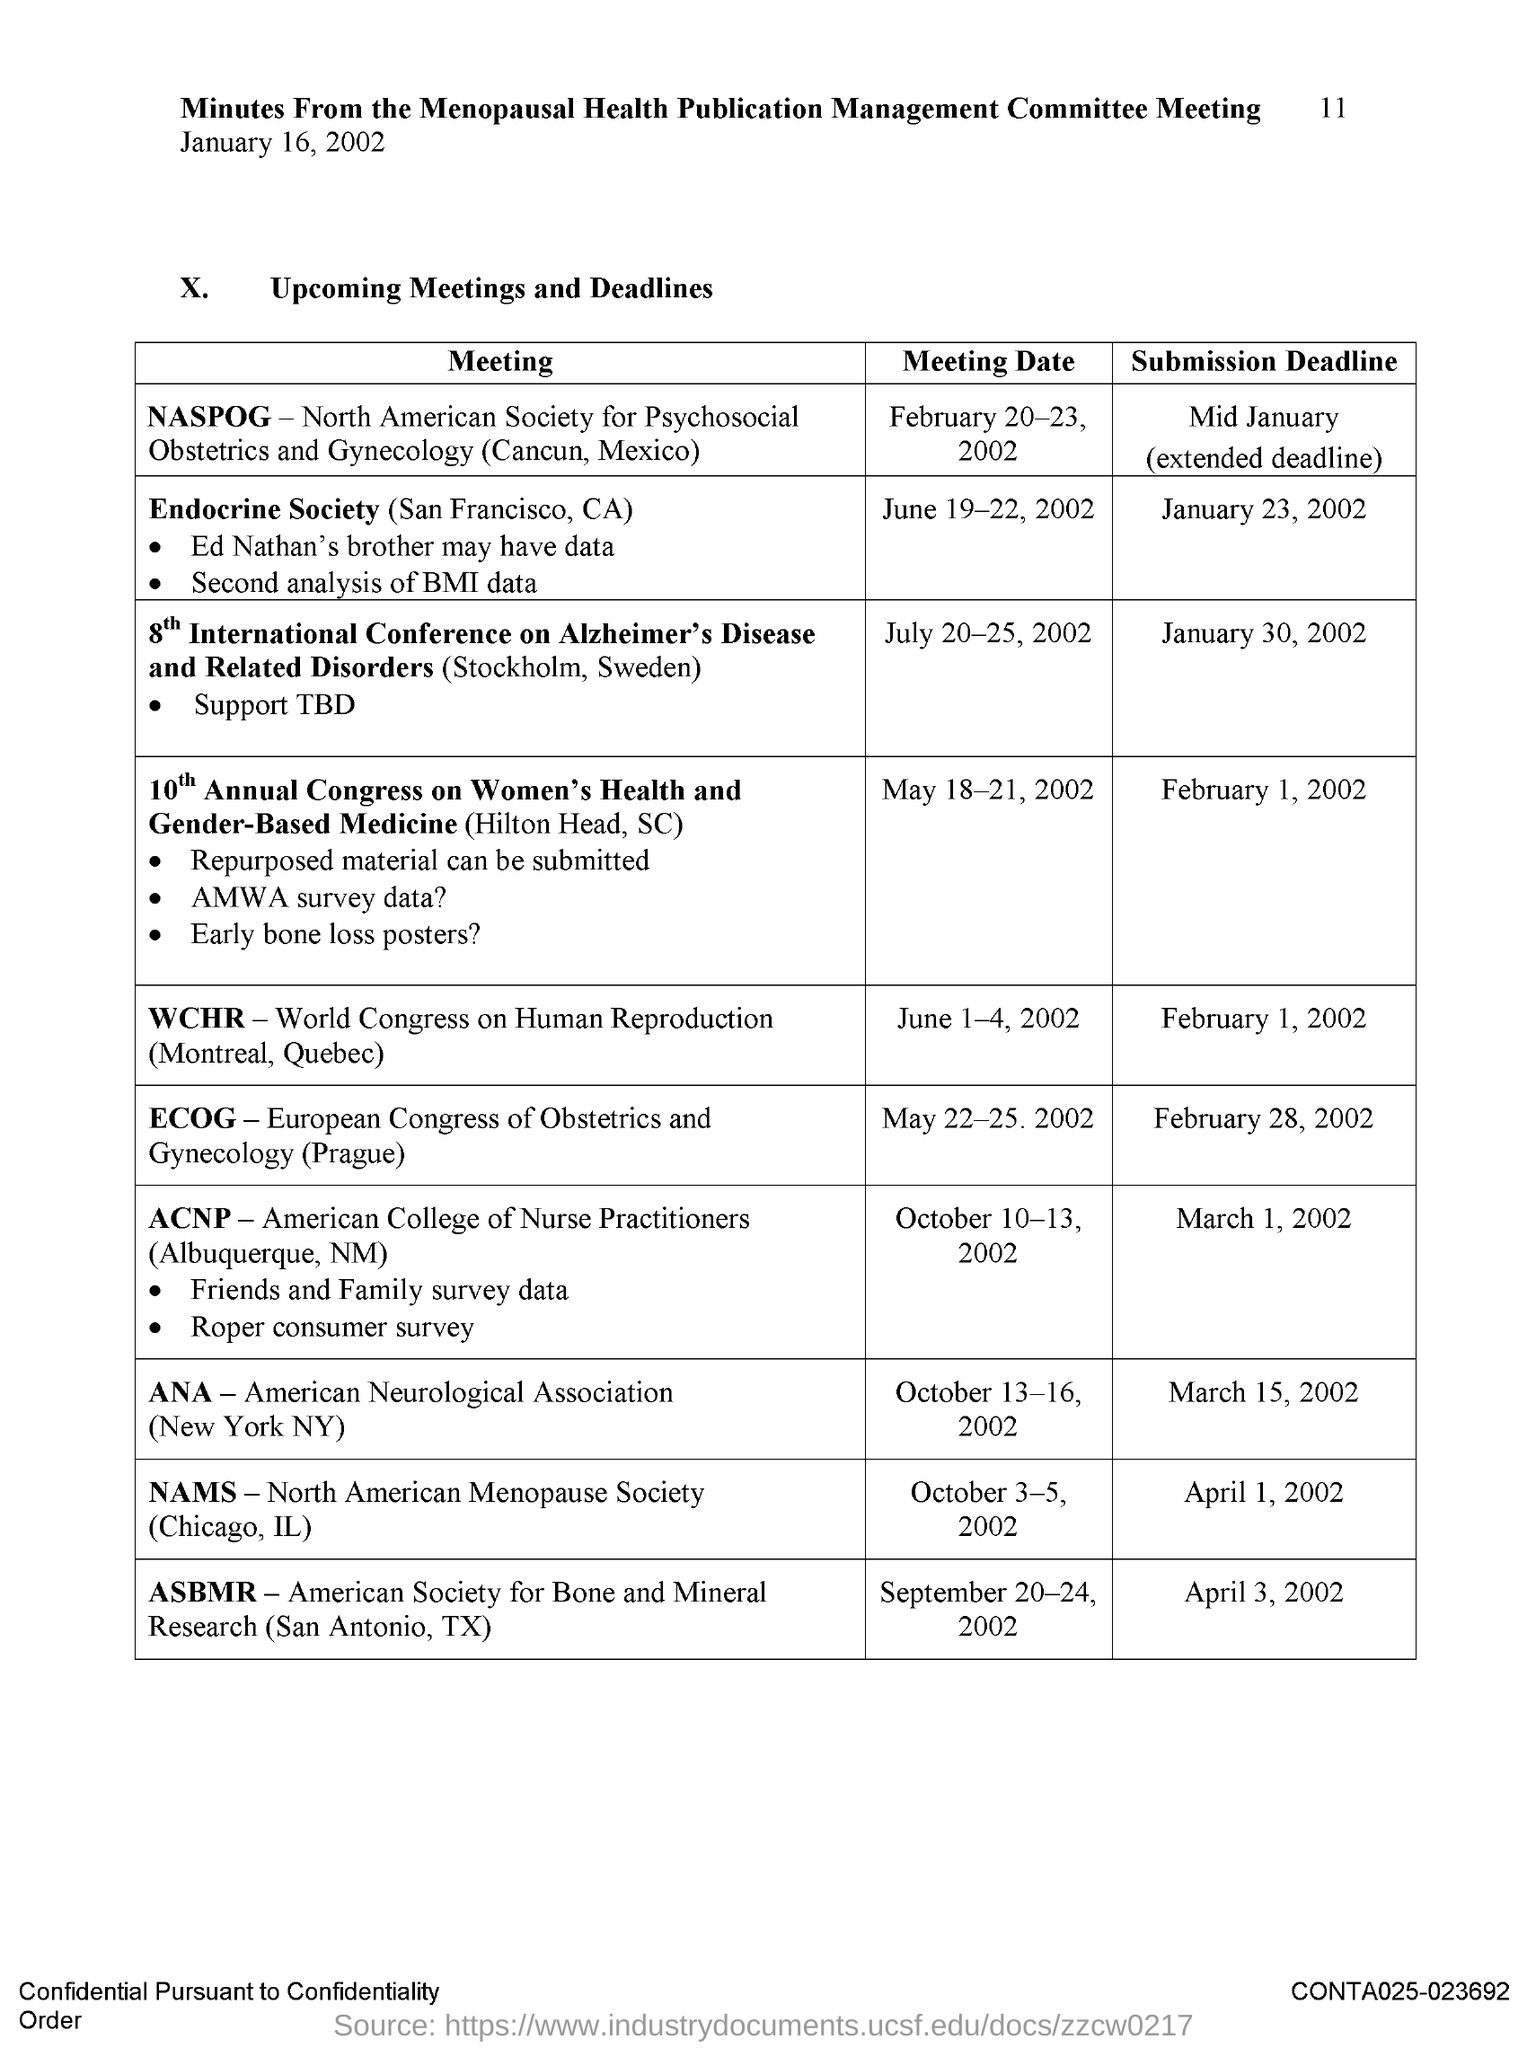What is the full form ANA?
Your answer should be very brief. American Neurological Association. What is the full form NAMS?
Provide a short and direct response. North American Menopause Society. What is the full form of WCHR?
Your response must be concise. World congress on human reproduction. 